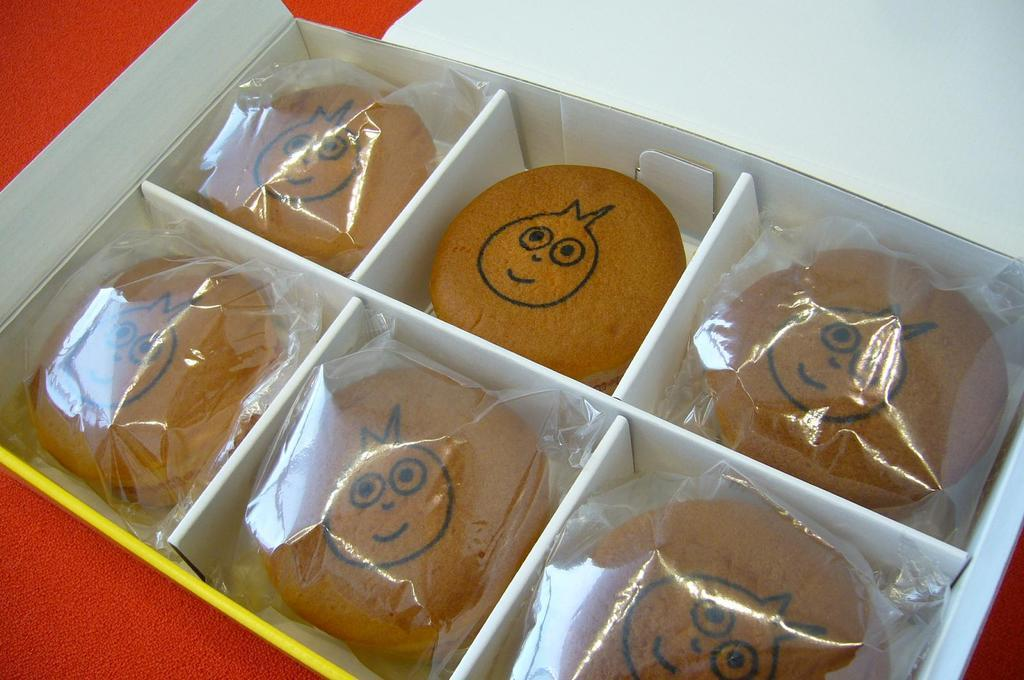What is the main object in the image? There is a box in the image. What is inside the box? There are six bread buns in the box. How are the bread buns packaged? Five of the bread buns are wrapped in a plastic cover. What team is playing in the afternoon in the image? There is no team or afternoon activity depicted in the image; it features a box with bread buns. Can you see a wristwatch on anyone's wrist in the image? There are no people or visible wrists in the image, so it is impossible to determine if there is a wristwatch present. 